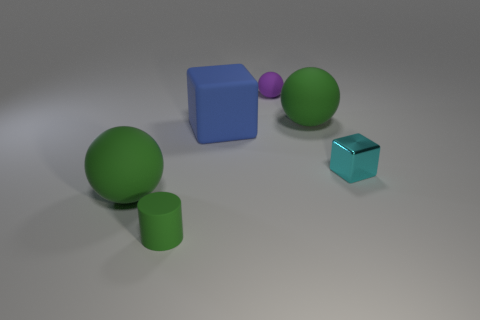Subtract all large green rubber balls. How many balls are left? 1 Add 2 tiny cyan objects. How many objects exist? 8 Subtract all cylinders. How many objects are left? 5 Subtract all tiny purple cubes. Subtract all green objects. How many objects are left? 3 Add 6 small green rubber cylinders. How many small green rubber cylinders are left? 7 Add 3 cubes. How many cubes exist? 5 Subtract 0 gray cubes. How many objects are left? 6 